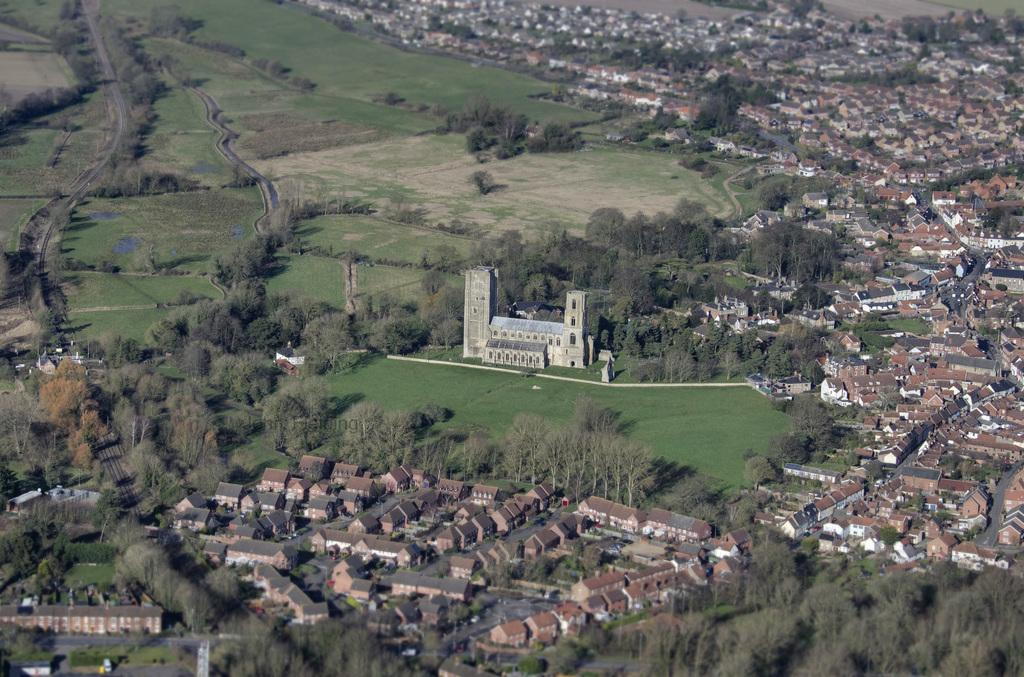What type of structures can be seen in the image? There are many houses with roofs in the image. What type of vegetation is present in the image? There are many trees and plants in the image. What covers the ground in the image? There is grass on the ground in the image. Can you tell me how many crows are sitting on the roof of the house in the image? There are no crows present in the image; it only features houses, trees, plants, and grass. 